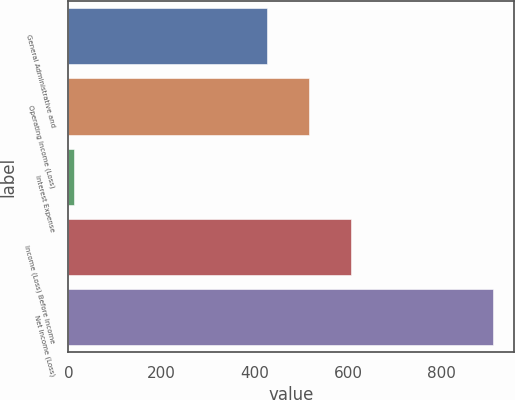<chart> <loc_0><loc_0><loc_500><loc_500><bar_chart><fcel>General Administrative and<fcel>Operating Income (Loss)<fcel>Interest Expense<fcel>Income (Loss) Before Income<fcel>Net Income (Loss)<nl><fcel>426<fcel>515.7<fcel>13<fcel>605.4<fcel>910<nl></chart> 